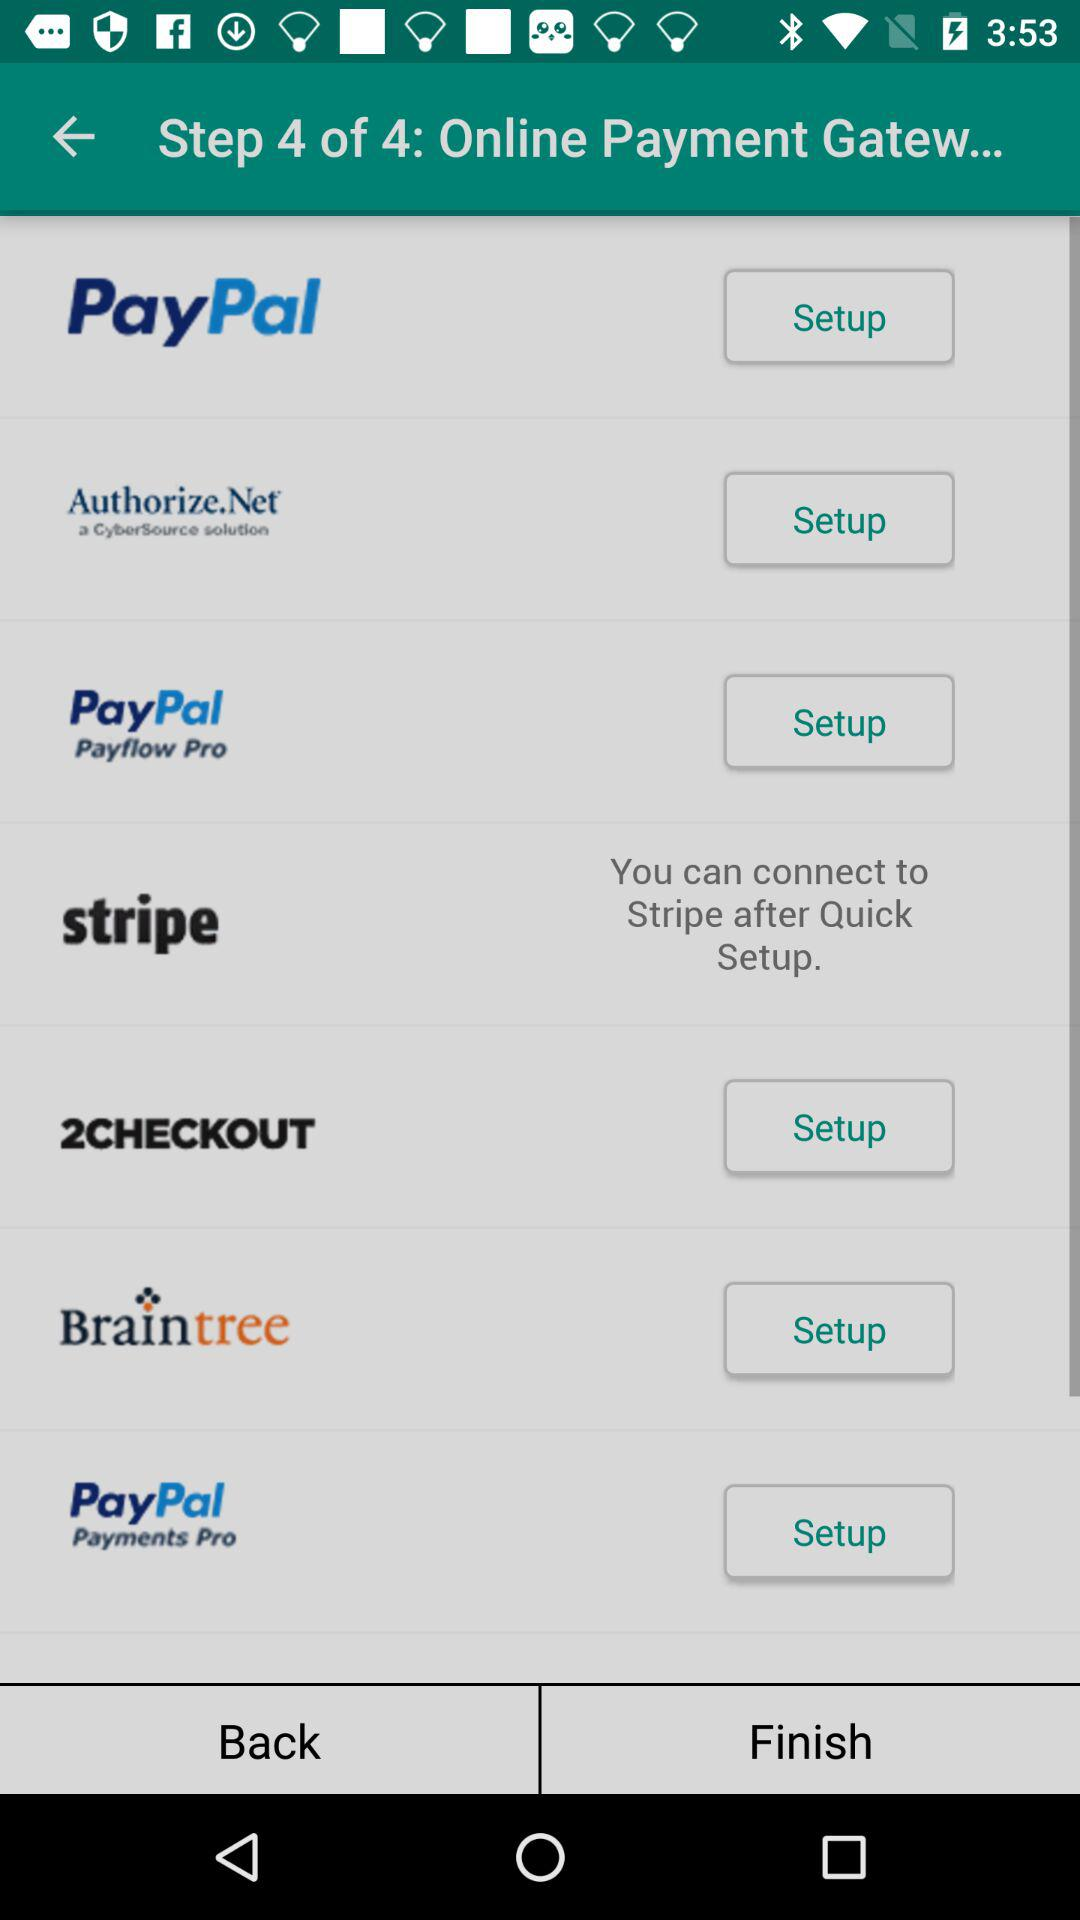Which step asks for a username and password?
When the provided information is insufficient, respond with <no answer>. <no answer> 